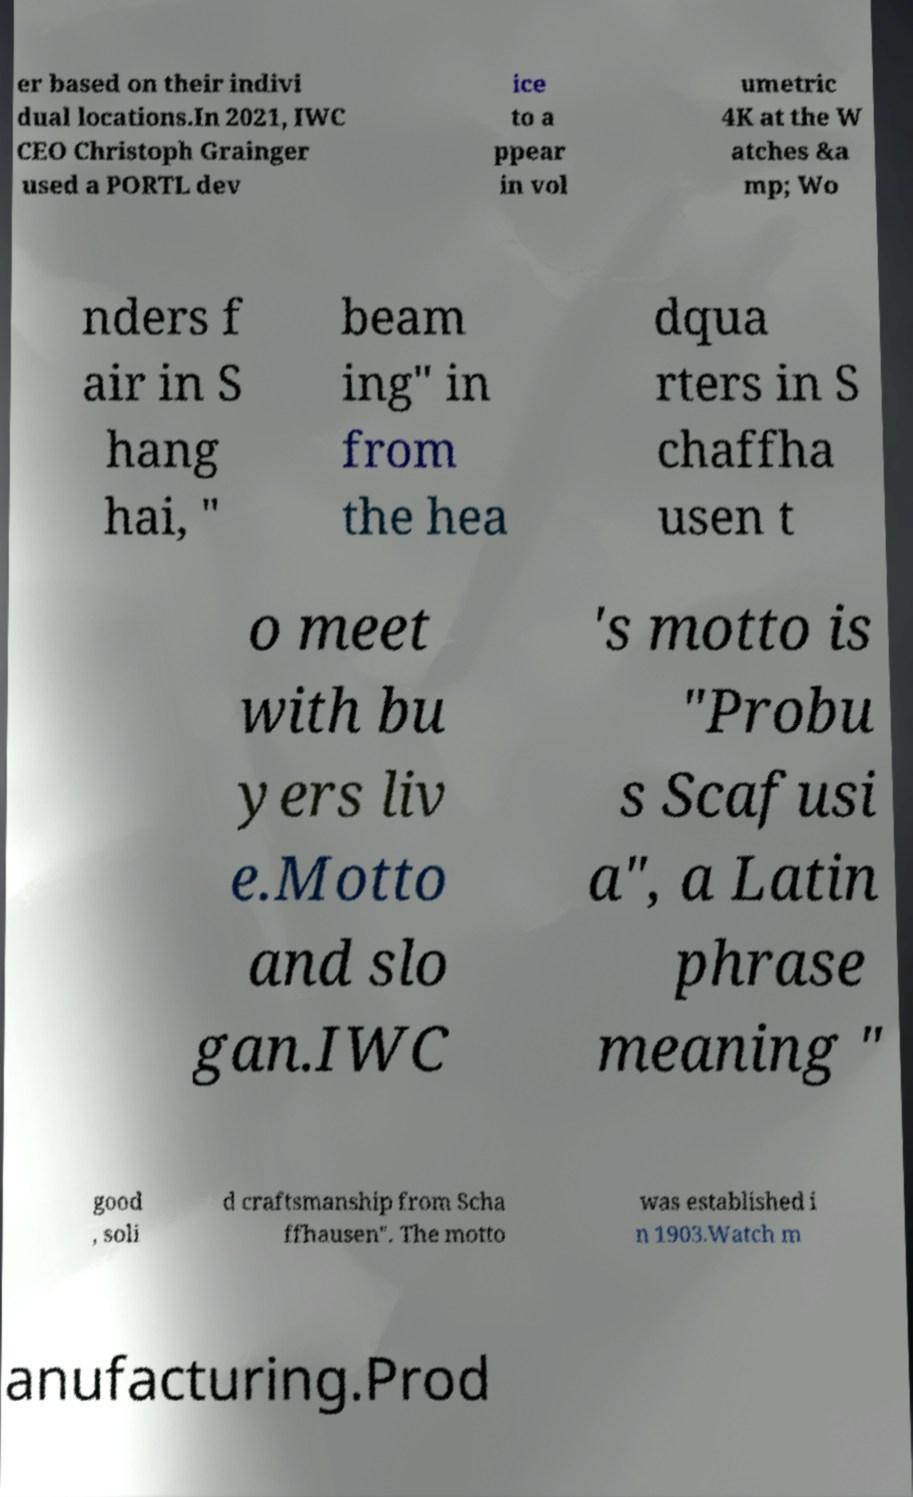Please identify and transcribe the text found in this image. er based on their indivi dual locations.In 2021, IWC CEO Christoph Grainger used a PORTL dev ice to a ppear in vol umetric 4K at the W atches &a mp; Wo nders f air in S hang hai, " beam ing" in from the hea dqua rters in S chaffha usen t o meet with bu yers liv e.Motto and slo gan.IWC 's motto is "Probu s Scafusi a", a Latin phrase meaning " good , soli d craftsmanship from Scha ffhausen". The motto was established i n 1903.Watch m anufacturing.Prod 